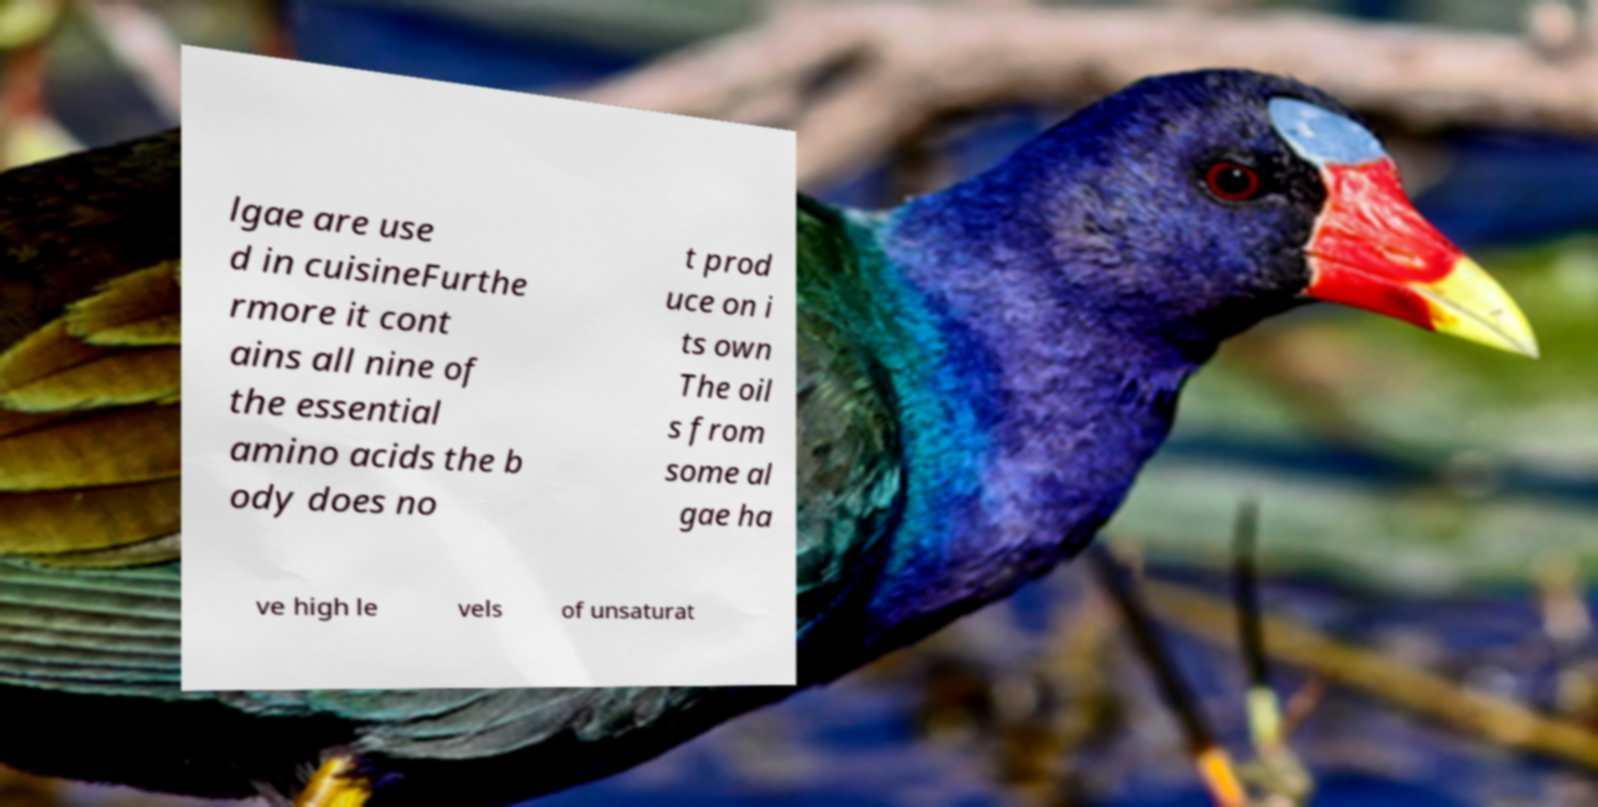Could you extract and type out the text from this image? lgae are use d in cuisineFurthe rmore it cont ains all nine of the essential amino acids the b ody does no t prod uce on i ts own The oil s from some al gae ha ve high le vels of unsaturat 